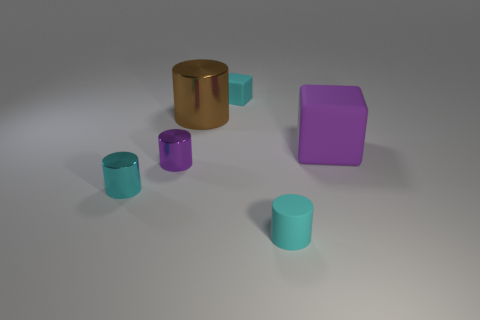What can you infer about the purpose of these objects? From the image, these objects seem to be simple geometric shapes that might be used for a variety of purposes, from educational tools to demonstrate geometric concepts, to elements in a visual composition for artistic or design purposes. 